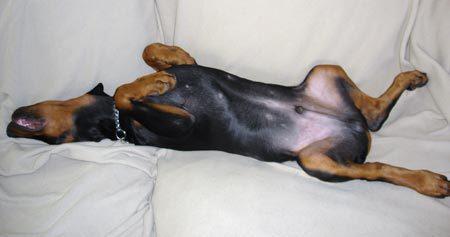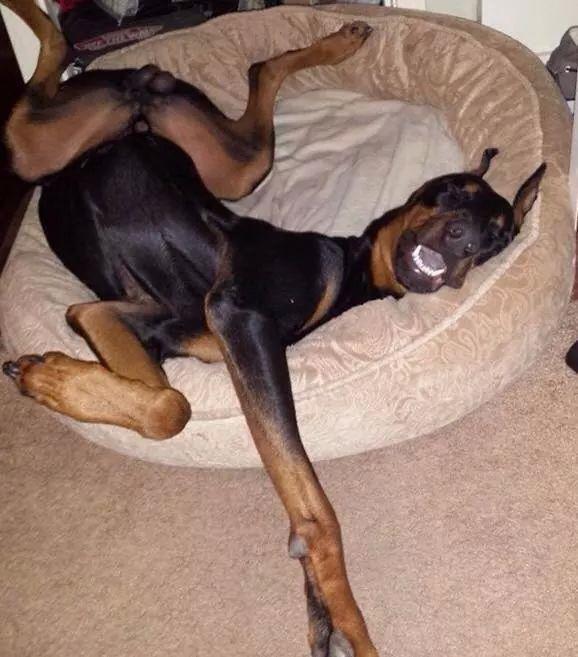The first image is the image on the left, the second image is the image on the right. Given the left and right images, does the statement "A person sitting on upholstered furniture on the left of one image is touching the belly of a dog lying on its back with its front paws bent forward and hind legs extended." hold true? Answer yes or no. No. The first image is the image on the left, the second image is the image on the right. Evaluate the accuracy of this statement regarding the images: "The dog in one of the images is getting its belly rubbed.". Is it true? Answer yes or no. No. 